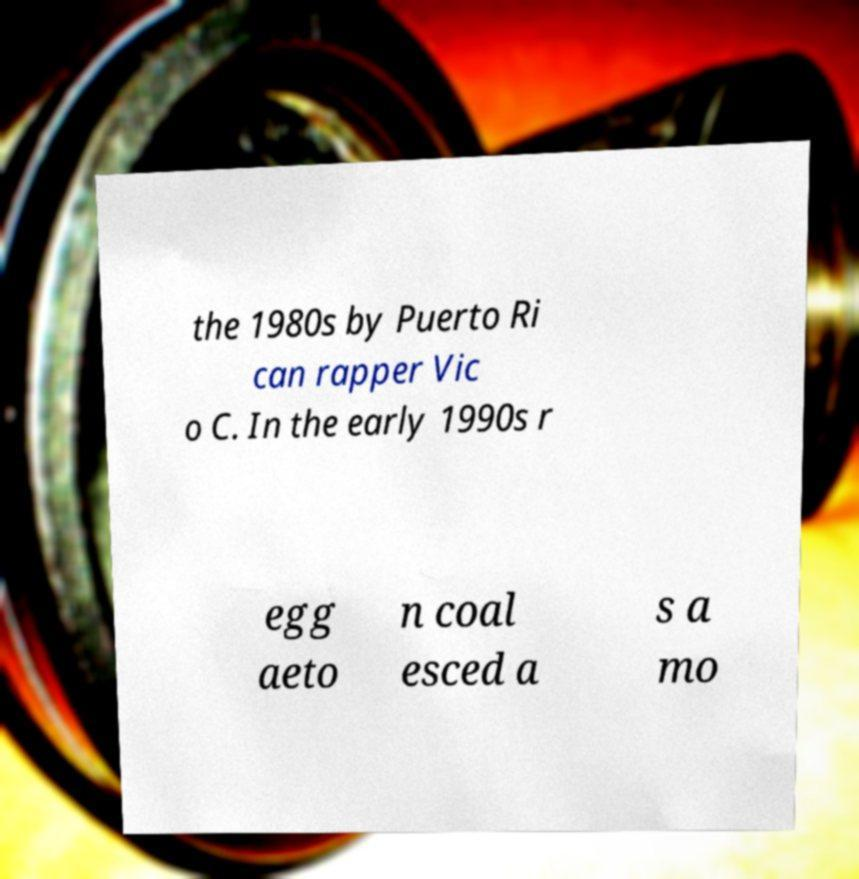Please read and relay the text visible in this image. What does it say? the 1980s by Puerto Ri can rapper Vic o C. In the early 1990s r egg aeto n coal esced a s a mo 